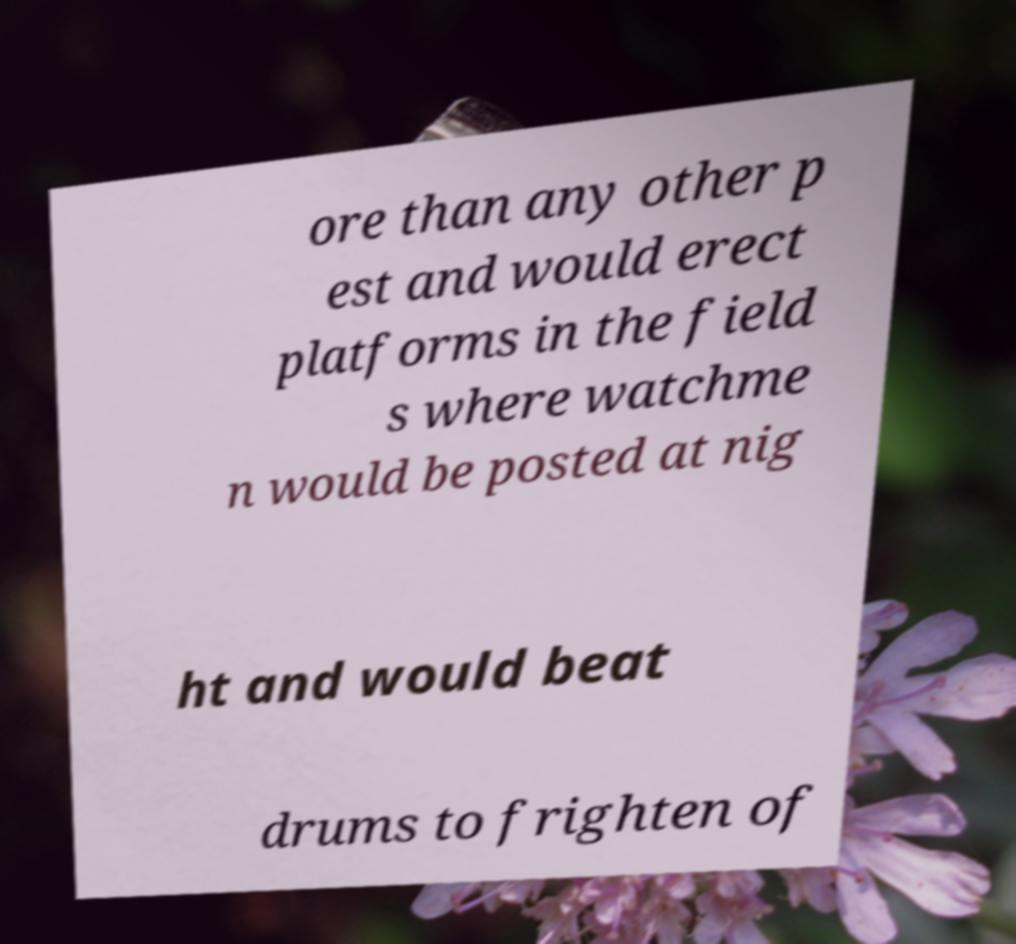Can you accurately transcribe the text from the provided image for me? ore than any other p est and would erect platforms in the field s where watchme n would be posted at nig ht and would beat drums to frighten of 